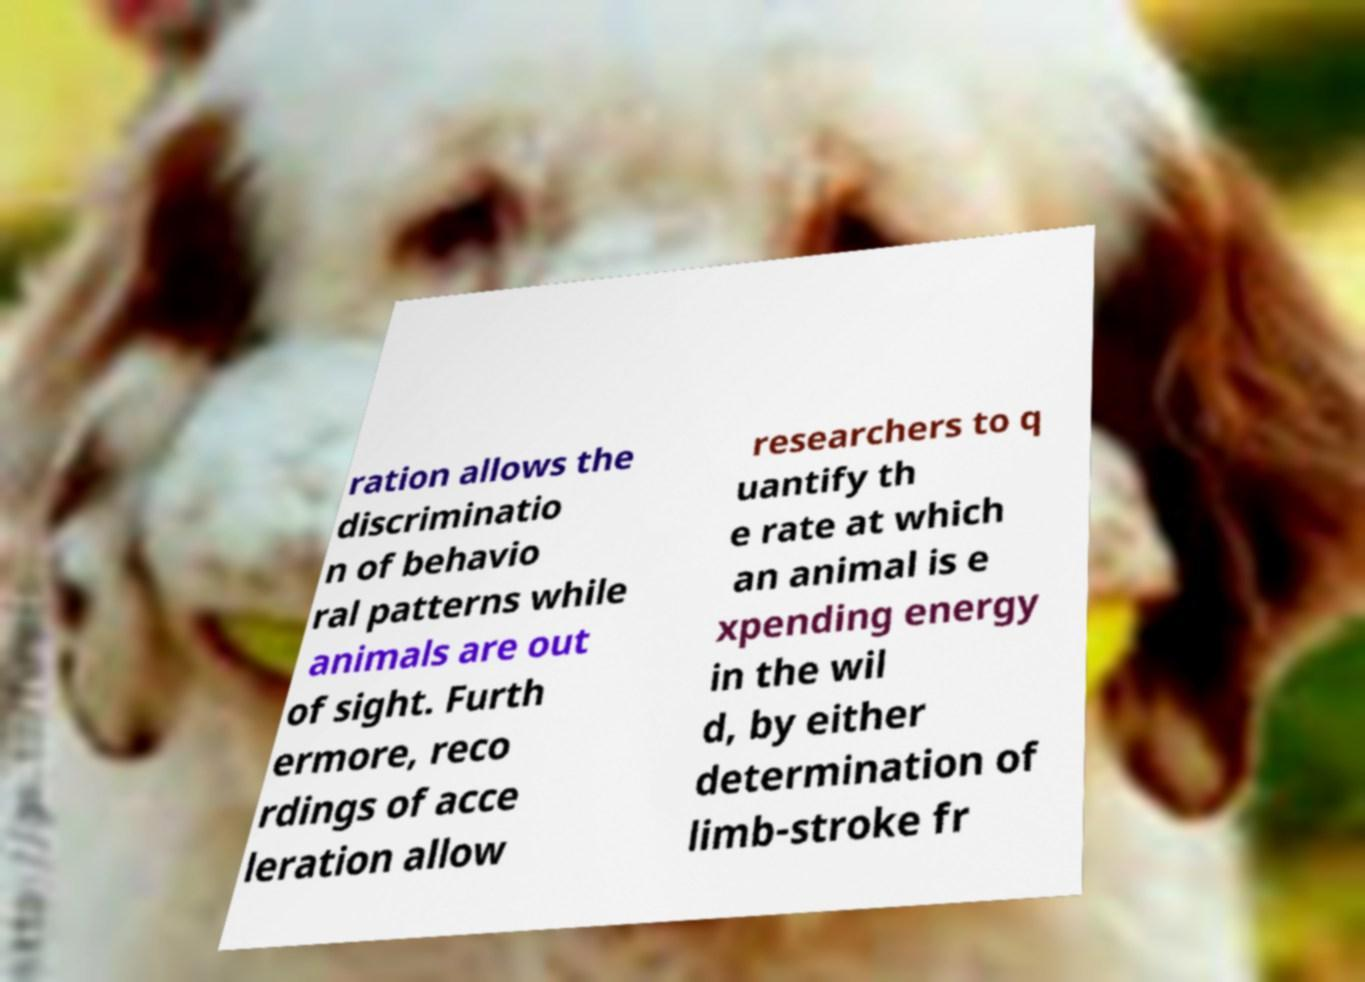I need the written content from this picture converted into text. Can you do that? ration allows the discriminatio n of behavio ral patterns while animals are out of sight. Furth ermore, reco rdings of acce leration allow researchers to q uantify th e rate at which an animal is e xpending energy in the wil d, by either determination of limb-stroke fr 